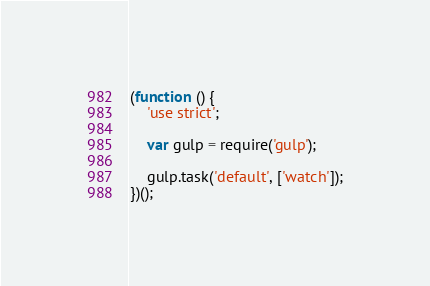Convert code to text. <code><loc_0><loc_0><loc_500><loc_500><_JavaScript_>(function () {
    'use strict';

    var gulp = require('gulp');

    gulp.task('default', ['watch']);
})();
</code> 